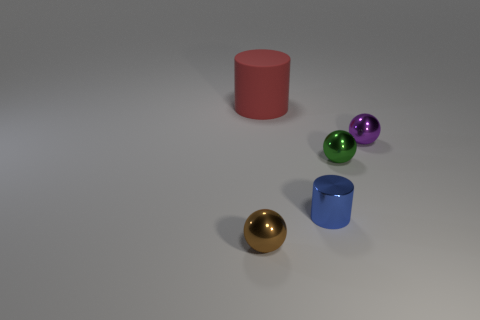Subtract all green metallic balls. How many balls are left? 2 Add 4 tiny red metallic blocks. How many objects exist? 9 Subtract all red cylinders. How many cylinders are left? 1 Subtract all cylinders. How many objects are left? 3 Subtract all purple metal objects. Subtract all big cyan metallic cylinders. How many objects are left? 4 Add 1 small purple metal balls. How many small purple metal balls are left? 2 Add 4 cyan rubber cylinders. How many cyan rubber cylinders exist? 4 Subtract 0 gray cubes. How many objects are left? 5 Subtract 1 spheres. How many spheres are left? 2 Subtract all cyan balls. Subtract all red cubes. How many balls are left? 3 